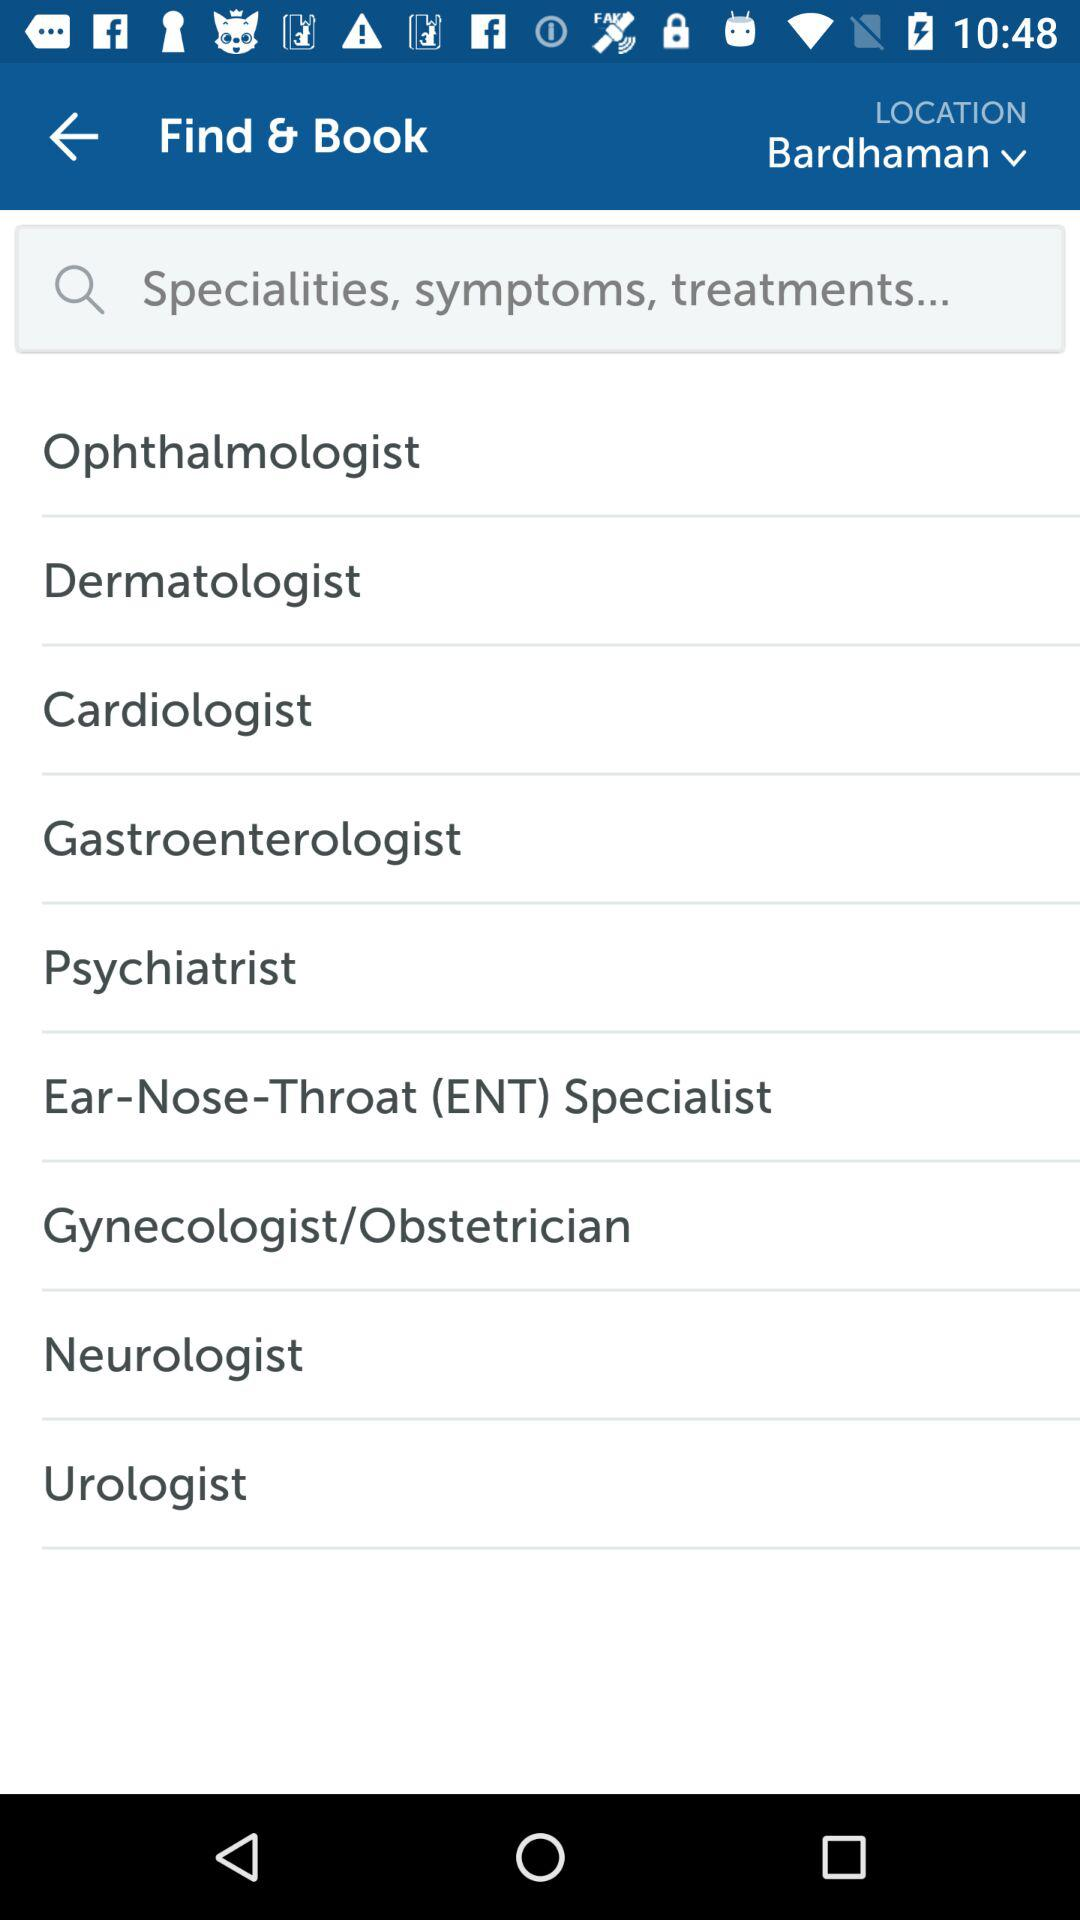What is the location? The location is Bardhaman. 